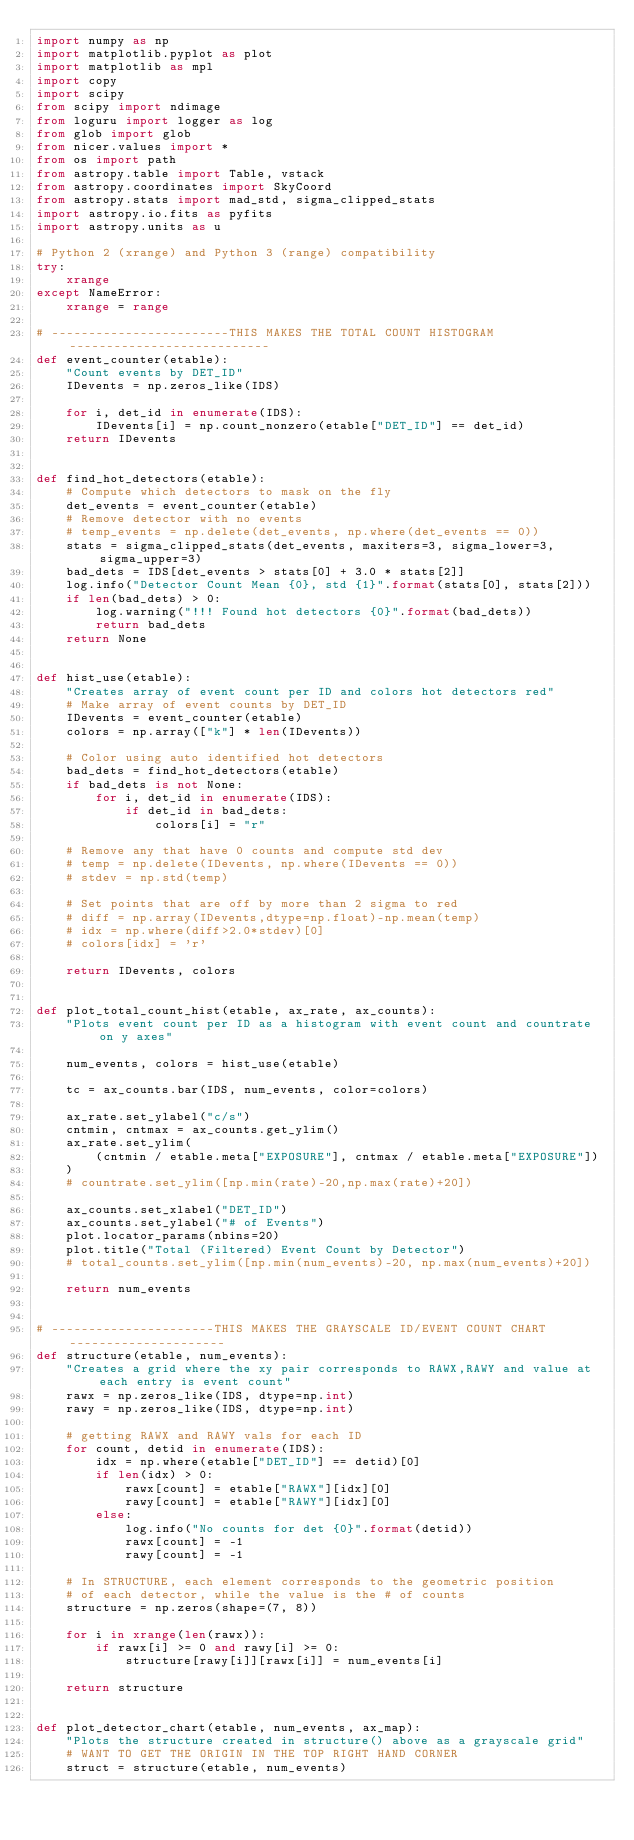<code> <loc_0><loc_0><loc_500><loc_500><_Python_>import numpy as np
import matplotlib.pyplot as plot
import matplotlib as mpl
import copy
import scipy
from scipy import ndimage
from loguru import logger as log
from glob import glob
from nicer.values import *
from os import path
from astropy.table import Table, vstack
from astropy.coordinates import SkyCoord
from astropy.stats import mad_std, sigma_clipped_stats
import astropy.io.fits as pyfits
import astropy.units as u

# Python 2 (xrange) and Python 3 (range) compatibility
try:
    xrange
except NameError:
    xrange = range

# ------------------------THIS MAKES THE TOTAL COUNT HISTOGRAM---------------------------
def event_counter(etable):
    "Count events by DET_ID"
    IDevents = np.zeros_like(IDS)

    for i, det_id in enumerate(IDS):
        IDevents[i] = np.count_nonzero(etable["DET_ID"] == det_id)
    return IDevents


def find_hot_detectors(etable):
    # Compute which detectors to mask on the fly
    det_events = event_counter(etable)
    # Remove detector with no events
    # temp_events = np.delete(det_events, np.where(det_events == 0))
    stats = sigma_clipped_stats(det_events, maxiters=3, sigma_lower=3, sigma_upper=3)
    bad_dets = IDS[det_events > stats[0] + 3.0 * stats[2]]
    log.info("Detector Count Mean {0}, std {1}".format(stats[0], stats[2]))
    if len(bad_dets) > 0:
        log.warning("!!! Found hot detectors {0}".format(bad_dets))
        return bad_dets
    return None


def hist_use(etable):
    "Creates array of event count per ID and colors hot detectors red"
    # Make array of event counts by DET_ID
    IDevents = event_counter(etable)
    colors = np.array(["k"] * len(IDevents))

    # Color using auto identified hot detectors
    bad_dets = find_hot_detectors(etable)
    if bad_dets is not None:
        for i, det_id in enumerate(IDS):
            if det_id in bad_dets:
                colors[i] = "r"

    # Remove any that have 0 counts and compute std dev
    # temp = np.delete(IDevents, np.where(IDevents == 0))
    # stdev = np.std(temp)

    # Set points that are off by more than 2 sigma to red
    # diff = np.array(IDevents,dtype=np.float)-np.mean(temp)
    # idx = np.where(diff>2.0*stdev)[0]
    # colors[idx] = 'r'

    return IDevents, colors


def plot_total_count_hist(etable, ax_rate, ax_counts):
    "Plots event count per ID as a histogram with event count and countrate on y axes"

    num_events, colors = hist_use(etable)

    tc = ax_counts.bar(IDS, num_events, color=colors)

    ax_rate.set_ylabel("c/s")
    cntmin, cntmax = ax_counts.get_ylim()
    ax_rate.set_ylim(
        (cntmin / etable.meta["EXPOSURE"], cntmax / etable.meta["EXPOSURE"])
    )
    # countrate.set_ylim([np.min(rate)-20,np.max(rate)+20])

    ax_counts.set_xlabel("DET_ID")
    ax_counts.set_ylabel("# of Events")
    plot.locator_params(nbins=20)
    plot.title("Total (Filtered) Event Count by Detector")
    # total_counts.set_ylim([np.min(num_events)-20, np.max(num_events)+20])

    return num_events


# ----------------------THIS MAKES THE GRAYSCALE ID/EVENT COUNT CHART---------------------
def structure(etable, num_events):
    "Creates a grid where the xy pair corresponds to RAWX,RAWY and value at each entry is event count"
    rawx = np.zeros_like(IDS, dtype=np.int)
    rawy = np.zeros_like(IDS, dtype=np.int)

    # getting RAWX and RAWY vals for each ID
    for count, detid in enumerate(IDS):
        idx = np.where(etable["DET_ID"] == detid)[0]
        if len(idx) > 0:
            rawx[count] = etable["RAWX"][idx][0]
            rawy[count] = etable["RAWY"][idx][0]
        else:
            log.info("No counts for det {0}".format(detid))
            rawx[count] = -1
            rawy[count] = -1

    # In STRUCTURE, each element corresponds to the geometric position
    # of each detector, while the value is the # of counts
    structure = np.zeros(shape=(7, 8))

    for i in xrange(len(rawx)):
        if rawx[i] >= 0 and rawy[i] >= 0:
            structure[rawy[i]][rawx[i]] = num_events[i]

    return structure


def plot_detector_chart(etable, num_events, ax_map):
    "Plots the structure created in structure() above as a grayscale grid"
    # WANT TO GET THE ORIGIN IN THE TOP RIGHT HAND CORNER
    struct = structure(etable, num_events)</code> 